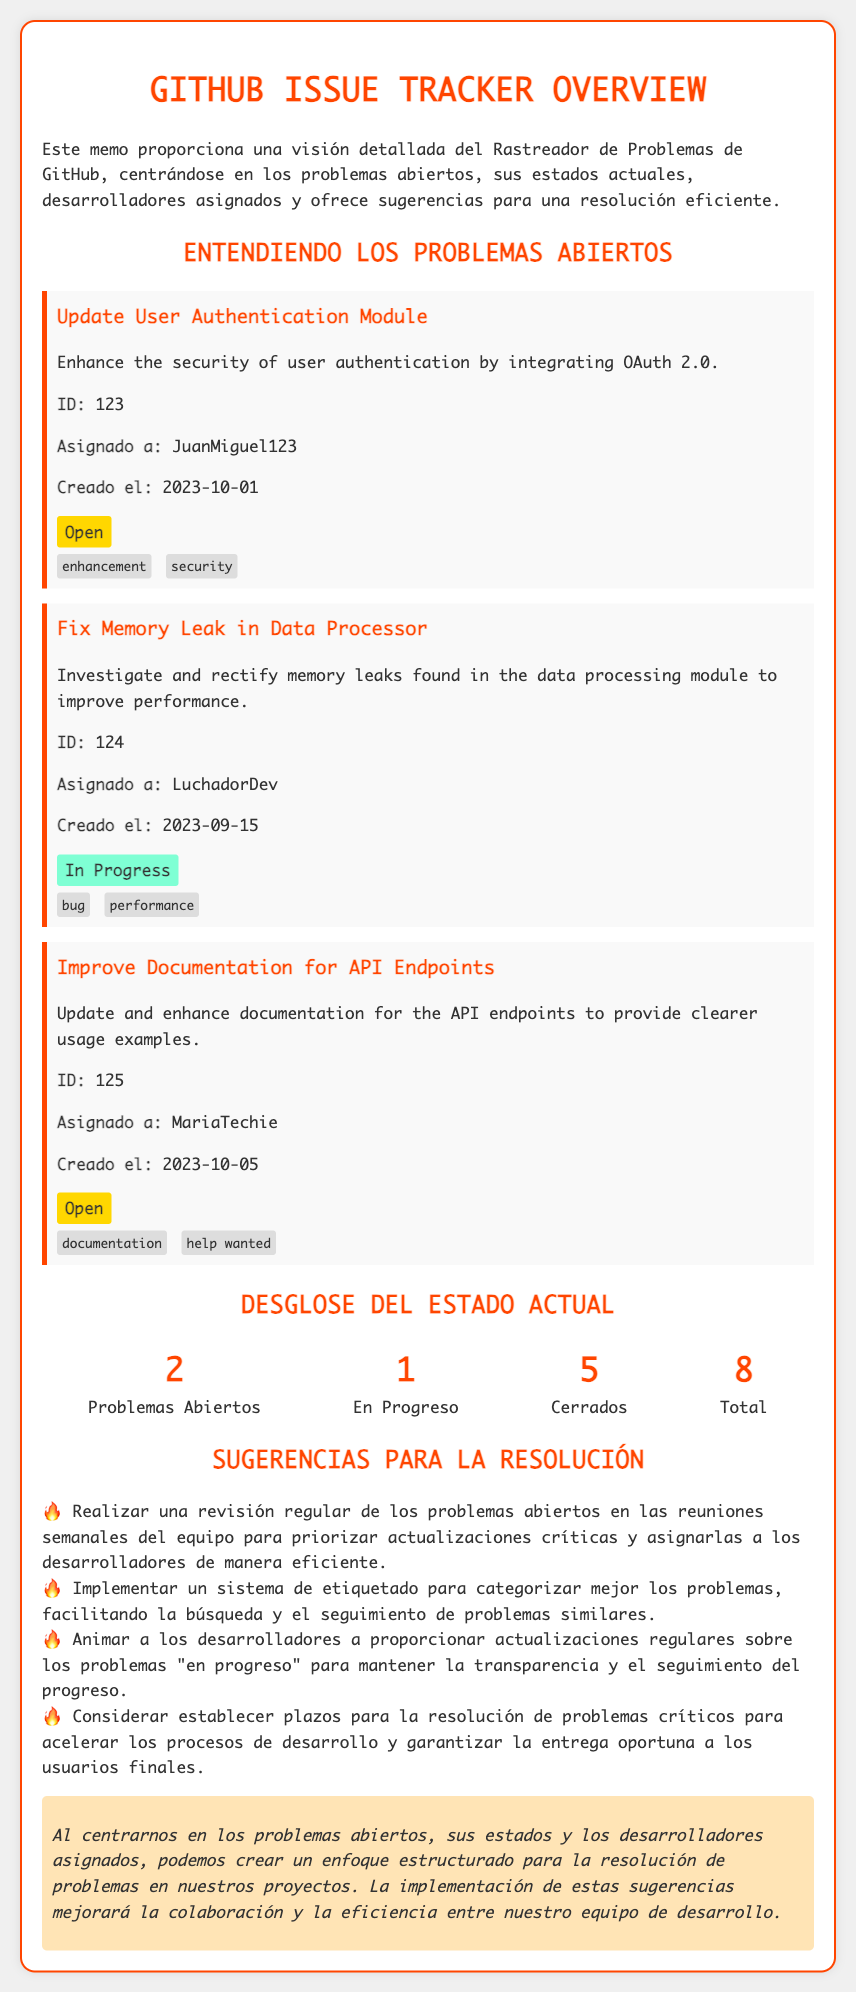¿Qué es el problema que se está abordando en el ID 123? El problema del ID 123 se centra en mejorar la seguridad de la autenticación de usuario mediante la integración de OAuth 2.0.
Answer: Update User Authentication Module ¿Quién está asignado al problema "Fix Memory Leak in Data Processor"? El documento indica que el problema "Fix Memory Leak in Data Processor" está asignado a LuchadorDev.
Answer: LuchadorDev ¿Cuántos problemas abiertos hay en total? La sección de desglose de estados señala que hay un total de 2 problemas abiertos.
Answer: 2 ¿Cuál es la fecha de creación del problema ID 125? Se menciona en el documento que el problema ID 125 fue creado el 2023-10-05.
Answer: 2023-10-05 ¿Qué tipo de problema es "Improve Documentation for API Endpoints"? El documento clasifica el problema "Improve Documentation for API Endpoints" como un problema de documentación.
Answer: documentation ¿Cuál es la sugerencia to improve el seguimiento de los problemas similares? Se sugiere implementar un sistema de etiquetado para categorizar mejor los problemas.
Answer: Sistema de etiquetado ¿Qué estado tiene el problema asignado a JuanMiguel123? El estado del problema asignado a JuanMiguel123 es "Open".
Answer: Open ¿Cuántos problemas en total se han cerrado según el desglose? Según el desglose, se han cerrado 5 problemas en total.
Answer: 5 